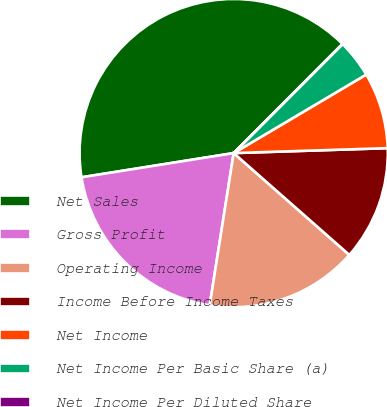<chart> <loc_0><loc_0><loc_500><loc_500><pie_chart><fcel>Net Sales<fcel>Gross Profit<fcel>Operating Income<fcel>Income Before Income Taxes<fcel>Net Income<fcel>Net Income Per Basic Share (a)<fcel>Net Income Per Diluted Share<nl><fcel>39.99%<fcel>20.0%<fcel>16.0%<fcel>12.0%<fcel>8.0%<fcel>4.0%<fcel>0.01%<nl></chart> 